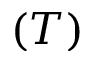Convert formula to latex. <formula><loc_0><loc_0><loc_500><loc_500>( T )</formula> 